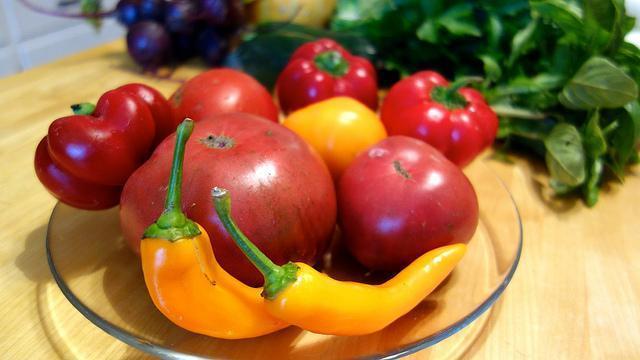How many people are wearing a checked top?
Give a very brief answer. 0. 